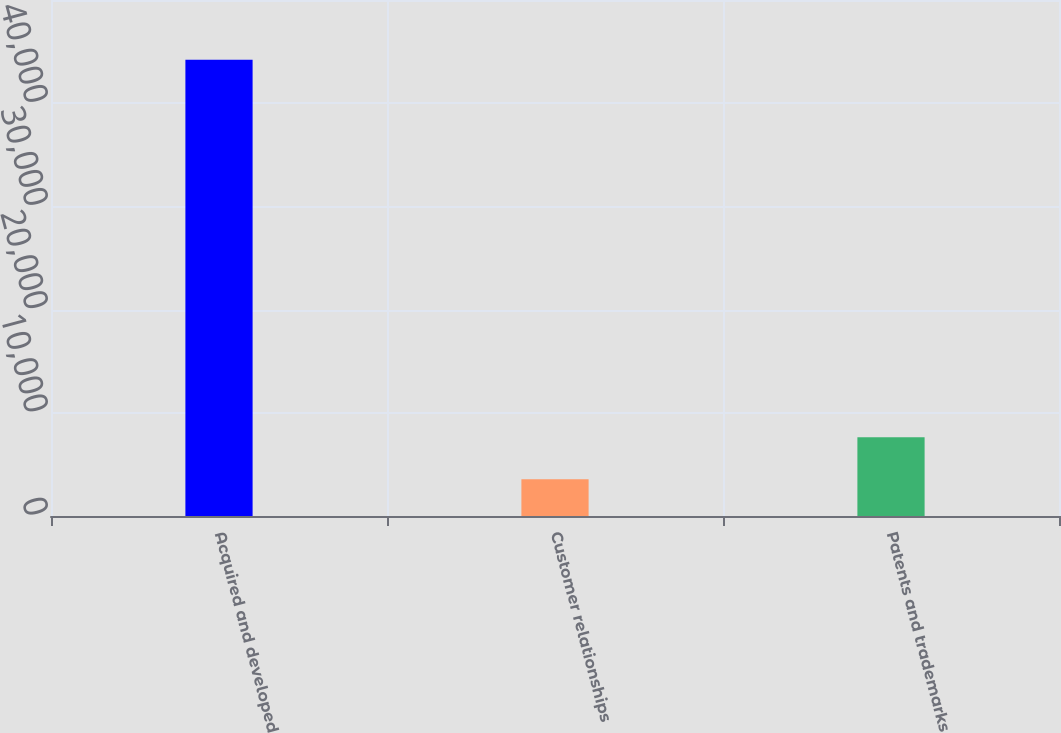<chart> <loc_0><loc_0><loc_500><loc_500><bar_chart><fcel>Acquired and developed<fcel>Customer relationships<fcel>Patents and trademarks<nl><fcel>44222<fcel>3552<fcel>7619<nl></chart> 